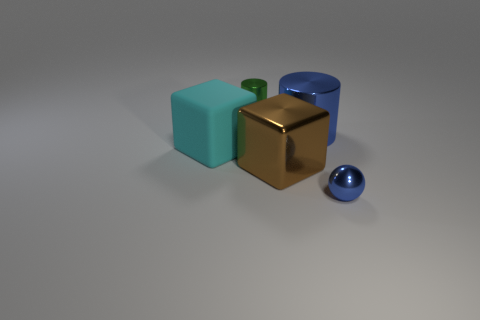Is there any other thing that is made of the same material as the big cyan block?
Your response must be concise. No. Is the number of blue cylinders that are behind the tiny cylinder the same as the number of large brown metallic things behind the large brown metallic thing?
Your answer should be compact. Yes. What number of other objects are there of the same material as the large cyan object?
Offer a terse response. 0. How many big objects are either blue things or blue cylinders?
Your answer should be compact. 1. Are there an equal number of green cylinders right of the tiny green shiny object and blue metal spheres?
Your answer should be compact. No. Is there a blue shiny object behind the tiny thing left of the big blue cylinder?
Give a very brief answer. No. How many other objects are there of the same color as the big cylinder?
Keep it short and to the point. 1. What is the color of the big shiny cube?
Provide a succinct answer. Brown. There is a metal thing that is both in front of the green cylinder and behind the brown thing; what size is it?
Keep it short and to the point. Large. What number of things are either big objects that are in front of the blue cylinder or small cylinders?
Provide a short and direct response. 3. 